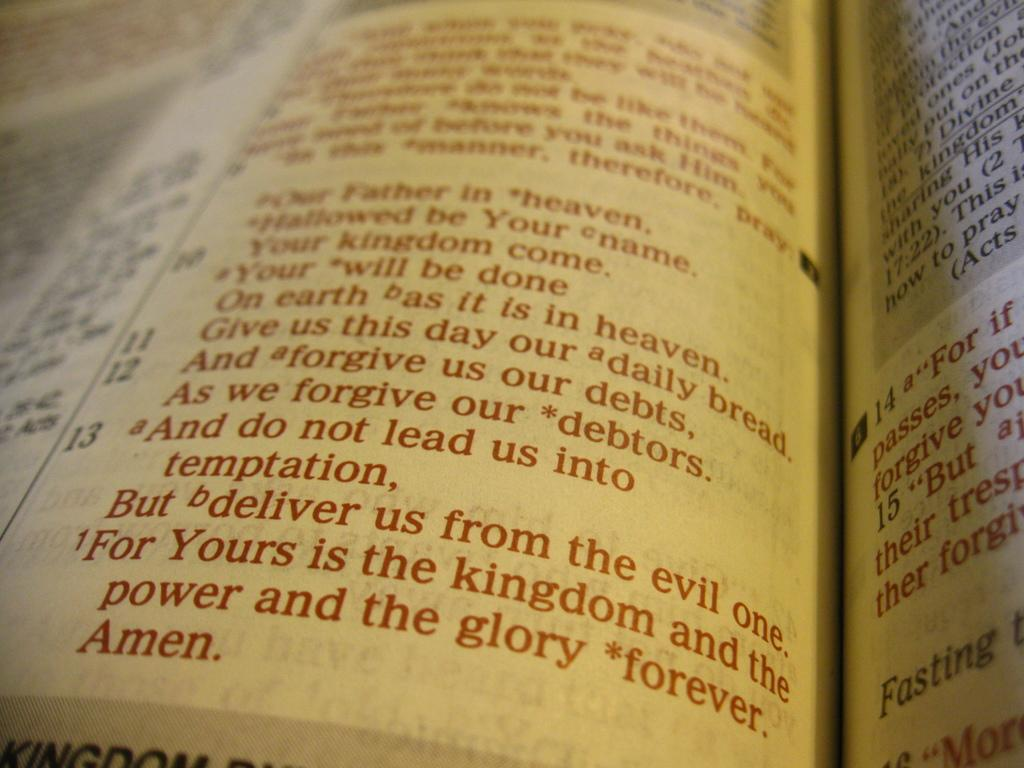<image>
Share a concise interpretation of the image provided. A Bible page is open to a passage that ends with the word Amen. 